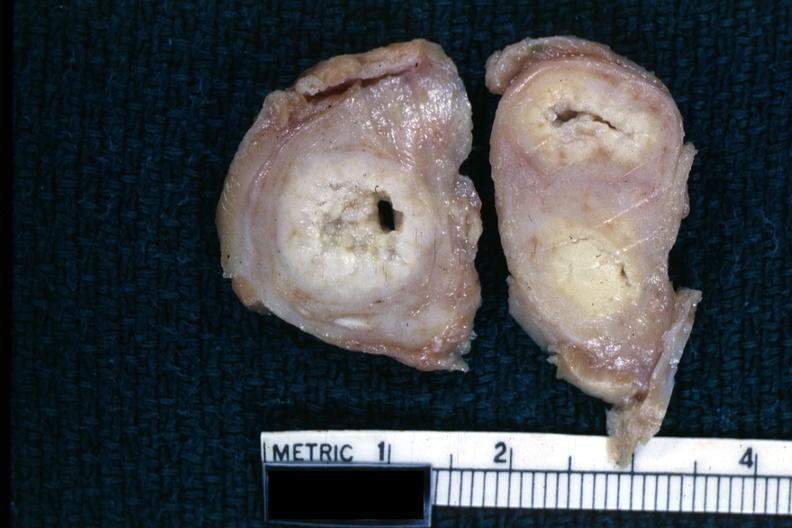does intraductal papillomatosis show fixed tissue of tuberculosis?
Answer the question using a single word or phrase. No 